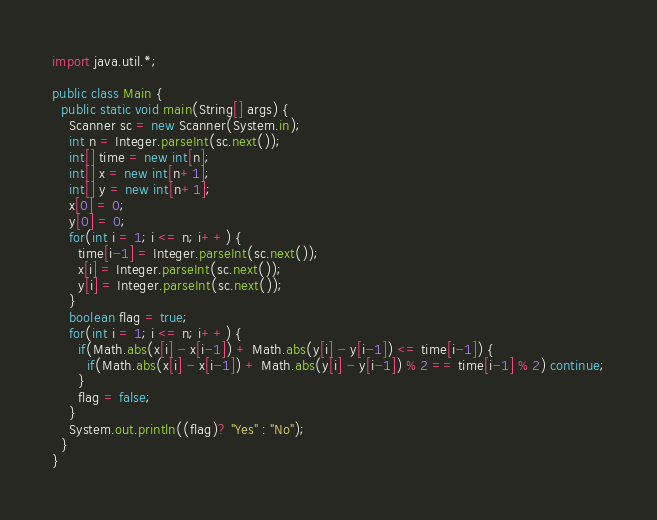<code> <loc_0><loc_0><loc_500><loc_500><_Java_>import java.util.*;

public class Main {
  public static void main(String[] args) {
    Scanner sc = new Scanner(System.in);
    int n = Integer.parseInt(sc.next());
    int[] time = new int[n];
    int[] x = new int[n+1];
    int[] y = new int[n+1];
    x[0] = 0;
    y[0] = 0;
    for(int i = 1; i <= n; i++) {
      time[i-1] = Integer.parseInt(sc.next());
      x[i] = Integer.parseInt(sc.next());
      y[i] = Integer.parseInt(sc.next());
    }
    boolean flag = true;
    for(int i = 1; i <= n; i++) {
      if(Math.abs(x[i] - x[i-1]) + Math.abs(y[i] - y[i-1]) <= time[i-1]) {
        if(Math.abs(x[i] - x[i-1]) + Math.abs(y[i] - y[i-1]) % 2 == time[i-1] % 2) continue;
      }
      flag = false;
    }
    System.out.println((flag)? "Yes" : "No");
  }
}
</code> 